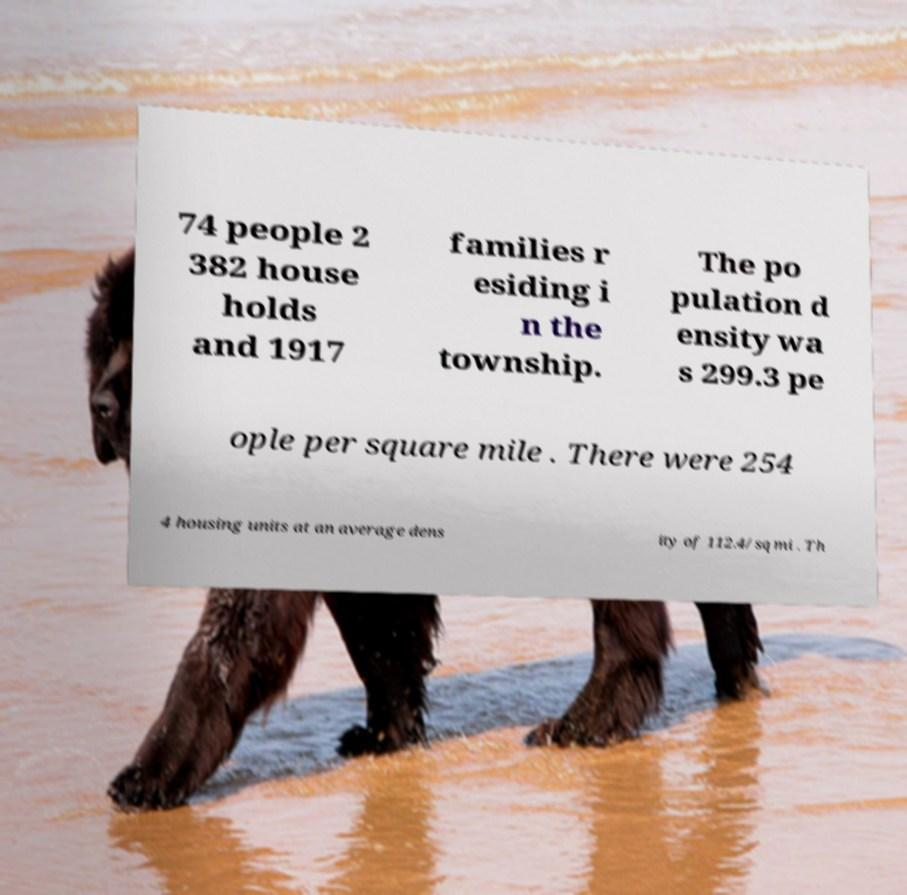Please identify and transcribe the text found in this image. 74 people 2 382 house holds and 1917 families r esiding i n the township. The po pulation d ensity wa s 299.3 pe ople per square mile . There were 254 4 housing units at an average dens ity of 112.4/sq mi . Th 